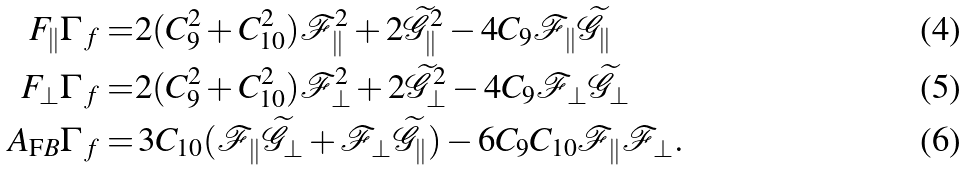<formula> <loc_0><loc_0><loc_500><loc_500>F _ { \| } \Gamma _ { \, f } = & 2 ( C _ { 9 } ^ { 2 } + C _ { 1 0 } ^ { 2 } ) \mathcal { F } _ { \| } ^ { 2 } + 2 \widetilde { \mathcal { G } } _ { \| } ^ { 2 } - 4 C _ { 9 } \mathcal { F } _ { \| } \widetilde { \mathcal { G } } _ { \| } \\ F _ { \perp } \Gamma _ { \, f } = & 2 ( C _ { 9 } ^ { 2 } + C _ { 1 0 } ^ { 2 } ) \mathcal { F } _ { \perp } ^ { 2 } + 2 \widetilde { \mathcal { G } } _ { \perp } ^ { 2 } - 4 C _ { 9 } \mathcal { F } _ { \perp } \widetilde { \mathcal { G } } _ { \perp } \\ A _ { \text  FB}\Gamma_{\, f}=&\,3 C_{10}(\mathcal{F}_{\|}\widetilde{\mathcal{G} } _ { \perp } + \mathcal { F } _ { \perp } \widetilde { \mathcal { G } } _ { \| } ) - 6 C _ { 9 } C _ { 1 0 } \mathcal { F } _ { \| } \mathcal { F } _ { \perp } .</formula> 